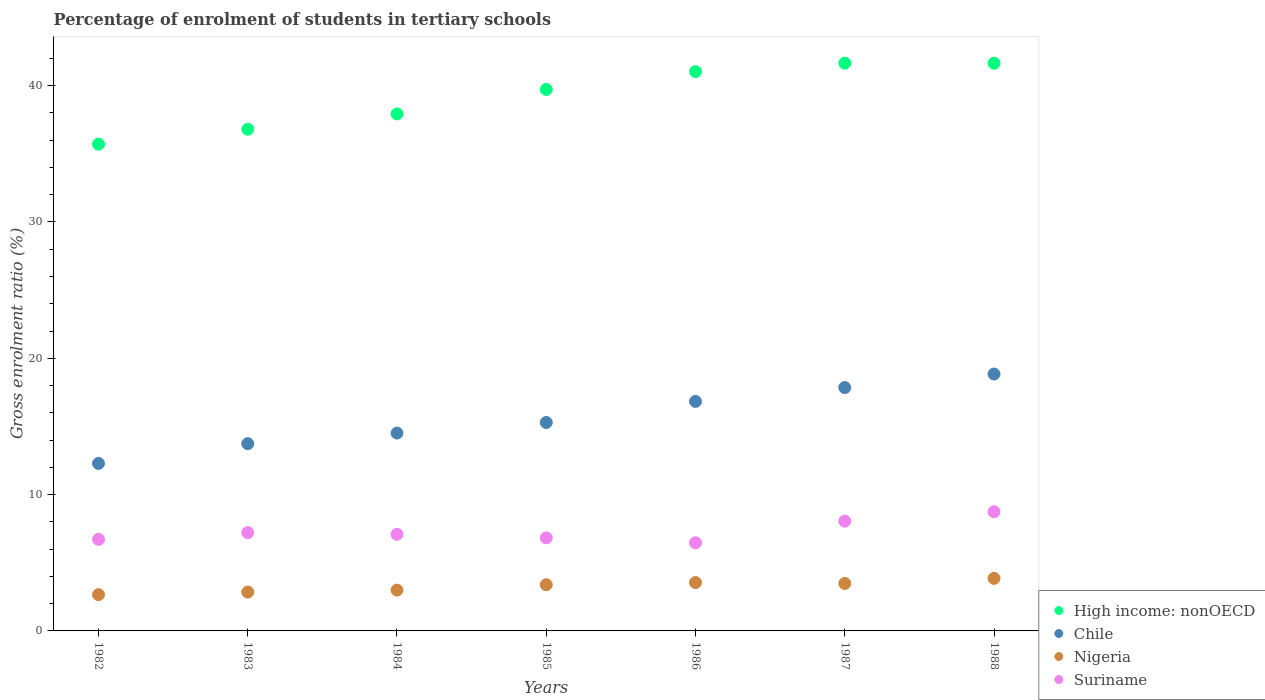Is the number of dotlines equal to the number of legend labels?
Give a very brief answer. Yes. What is the percentage of students enrolled in tertiary schools in Chile in 1984?
Provide a succinct answer. 14.51. Across all years, what is the maximum percentage of students enrolled in tertiary schools in Nigeria?
Your response must be concise. 3.85. Across all years, what is the minimum percentage of students enrolled in tertiary schools in Chile?
Keep it short and to the point. 12.29. In which year was the percentage of students enrolled in tertiary schools in Chile minimum?
Offer a terse response. 1982. What is the total percentage of students enrolled in tertiary schools in Nigeria in the graph?
Your response must be concise. 22.78. What is the difference between the percentage of students enrolled in tertiary schools in Suriname in 1984 and that in 1988?
Give a very brief answer. -1.66. What is the difference between the percentage of students enrolled in tertiary schools in High income: nonOECD in 1983 and the percentage of students enrolled in tertiary schools in Suriname in 1986?
Your answer should be compact. 30.33. What is the average percentage of students enrolled in tertiary schools in High income: nonOECD per year?
Ensure brevity in your answer.  39.21. In the year 1982, what is the difference between the percentage of students enrolled in tertiary schools in Chile and percentage of students enrolled in tertiary schools in Nigeria?
Make the answer very short. 9.63. In how many years, is the percentage of students enrolled in tertiary schools in High income: nonOECD greater than 8 %?
Your answer should be compact. 7. What is the ratio of the percentage of students enrolled in tertiary schools in Nigeria in 1982 to that in 1984?
Your response must be concise. 0.89. Is the percentage of students enrolled in tertiary schools in Suriname in 1987 less than that in 1988?
Offer a very short reply. Yes. What is the difference between the highest and the second highest percentage of students enrolled in tertiary schools in High income: nonOECD?
Offer a very short reply. 0.01. What is the difference between the highest and the lowest percentage of students enrolled in tertiary schools in Suriname?
Give a very brief answer. 2.28. In how many years, is the percentage of students enrolled in tertiary schools in Chile greater than the average percentage of students enrolled in tertiary schools in Chile taken over all years?
Keep it short and to the point. 3. Is it the case that in every year, the sum of the percentage of students enrolled in tertiary schools in Nigeria and percentage of students enrolled in tertiary schools in Suriname  is greater than the sum of percentage of students enrolled in tertiary schools in Chile and percentage of students enrolled in tertiary schools in High income: nonOECD?
Offer a terse response. Yes. Does the percentage of students enrolled in tertiary schools in Nigeria monotonically increase over the years?
Offer a terse response. No. Is the percentage of students enrolled in tertiary schools in Chile strictly greater than the percentage of students enrolled in tertiary schools in Suriname over the years?
Your answer should be compact. Yes. Is the percentage of students enrolled in tertiary schools in High income: nonOECD strictly less than the percentage of students enrolled in tertiary schools in Nigeria over the years?
Provide a short and direct response. No. How many dotlines are there?
Your answer should be very brief. 4. Are the values on the major ticks of Y-axis written in scientific E-notation?
Give a very brief answer. No. Does the graph contain any zero values?
Make the answer very short. No. Does the graph contain grids?
Your answer should be compact. No. How are the legend labels stacked?
Your answer should be very brief. Vertical. What is the title of the graph?
Offer a very short reply. Percentage of enrolment of students in tertiary schools. What is the label or title of the X-axis?
Make the answer very short. Years. What is the Gross enrolment ratio (%) of High income: nonOECD in 1982?
Give a very brief answer. 35.71. What is the Gross enrolment ratio (%) in Chile in 1982?
Offer a terse response. 12.29. What is the Gross enrolment ratio (%) of Nigeria in 1982?
Provide a succinct answer. 2.66. What is the Gross enrolment ratio (%) of Suriname in 1982?
Your answer should be compact. 6.72. What is the Gross enrolment ratio (%) of High income: nonOECD in 1983?
Give a very brief answer. 36.8. What is the Gross enrolment ratio (%) in Chile in 1983?
Offer a terse response. 13.74. What is the Gross enrolment ratio (%) of Nigeria in 1983?
Your answer should be very brief. 2.85. What is the Gross enrolment ratio (%) in Suriname in 1983?
Your answer should be compact. 7.21. What is the Gross enrolment ratio (%) in High income: nonOECD in 1984?
Your response must be concise. 37.92. What is the Gross enrolment ratio (%) of Chile in 1984?
Your answer should be very brief. 14.51. What is the Gross enrolment ratio (%) of Nigeria in 1984?
Provide a short and direct response. 2.99. What is the Gross enrolment ratio (%) of Suriname in 1984?
Make the answer very short. 7.09. What is the Gross enrolment ratio (%) of High income: nonOECD in 1985?
Ensure brevity in your answer.  39.72. What is the Gross enrolment ratio (%) of Chile in 1985?
Offer a terse response. 15.29. What is the Gross enrolment ratio (%) of Nigeria in 1985?
Ensure brevity in your answer.  3.39. What is the Gross enrolment ratio (%) of Suriname in 1985?
Offer a terse response. 6.83. What is the Gross enrolment ratio (%) of High income: nonOECD in 1986?
Give a very brief answer. 41.03. What is the Gross enrolment ratio (%) of Chile in 1986?
Ensure brevity in your answer.  16.84. What is the Gross enrolment ratio (%) in Nigeria in 1986?
Make the answer very short. 3.55. What is the Gross enrolment ratio (%) in Suriname in 1986?
Make the answer very short. 6.47. What is the Gross enrolment ratio (%) in High income: nonOECD in 1987?
Your response must be concise. 41.65. What is the Gross enrolment ratio (%) of Chile in 1987?
Your response must be concise. 17.85. What is the Gross enrolment ratio (%) in Nigeria in 1987?
Provide a succinct answer. 3.48. What is the Gross enrolment ratio (%) of Suriname in 1987?
Your response must be concise. 8.05. What is the Gross enrolment ratio (%) of High income: nonOECD in 1988?
Make the answer very short. 41.64. What is the Gross enrolment ratio (%) of Chile in 1988?
Offer a very short reply. 18.84. What is the Gross enrolment ratio (%) in Nigeria in 1988?
Your answer should be very brief. 3.85. What is the Gross enrolment ratio (%) in Suriname in 1988?
Provide a short and direct response. 8.74. Across all years, what is the maximum Gross enrolment ratio (%) in High income: nonOECD?
Provide a short and direct response. 41.65. Across all years, what is the maximum Gross enrolment ratio (%) in Chile?
Your response must be concise. 18.84. Across all years, what is the maximum Gross enrolment ratio (%) of Nigeria?
Provide a short and direct response. 3.85. Across all years, what is the maximum Gross enrolment ratio (%) in Suriname?
Offer a very short reply. 8.74. Across all years, what is the minimum Gross enrolment ratio (%) of High income: nonOECD?
Your response must be concise. 35.71. Across all years, what is the minimum Gross enrolment ratio (%) in Chile?
Offer a very short reply. 12.29. Across all years, what is the minimum Gross enrolment ratio (%) of Nigeria?
Provide a short and direct response. 2.66. Across all years, what is the minimum Gross enrolment ratio (%) of Suriname?
Make the answer very short. 6.47. What is the total Gross enrolment ratio (%) in High income: nonOECD in the graph?
Provide a succinct answer. 274.47. What is the total Gross enrolment ratio (%) in Chile in the graph?
Your response must be concise. 109.36. What is the total Gross enrolment ratio (%) of Nigeria in the graph?
Your answer should be very brief. 22.78. What is the total Gross enrolment ratio (%) of Suriname in the graph?
Provide a short and direct response. 51.1. What is the difference between the Gross enrolment ratio (%) in High income: nonOECD in 1982 and that in 1983?
Provide a short and direct response. -1.09. What is the difference between the Gross enrolment ratio (%) of Chile in 1982 and that in 1983?
Provide a short and direct response. -1.45. What is the difference between the Gross enrolment ratio (%) of Nigeria in 1982 and that in 1983?
Keep it short and to the point. -0.19. What is the difference between the Gross enrolment ratio (%) in Suriname in 1982 and that in 1983?
Keep it short and to the point. -0.49. What is the difference between the Gross enrolment ratio (%) of High income: nonOECD in 1982 and that in 1984?
Your answer should be compact. -2.22. What is the difference between the Gross enrolment ratio (%) in Chile in 1982 and that in 1984?
Your response must be concise. -2.23. What is the difference between the Gross enrolment ratio (%) in Nigeria in 1982 and that in 1984?
Ensure brevity in your answer.  -0.33. What is the difference between the Gross enrolment ratio (%) of Suriname in 1982 and that in 1984?
Provide a short and direct response. -0.37. What is the difference between the Gross enrolment ratio (%) of High income: nonOECD in 1982 and that in 1985?
Make the answer very short. -4.01. What is the difference between the Gross enrolment ratio (%) of Chile in 1982 and that in 1985?
Make the answer very short. -3. What is the difference between the Gross enrolment ratio (%) of Nigeria in 1982 and that in 1985?
Ensure brevity in your answer.  -0.73. What is the difference between the Gross enrolment ratio (%) of Suriname in 1982 and that in 1985?
Your response must be concise. -0.11. What is the difference between the Gross enrolment ratio (%) in High income: nonOECD in 1982 and that in 1986?
Ensure brevity in your answer.  -5.32. What is the difference between the Gross enrolment ratio (%) of Chile in 1982 and that in 1986?
Ensure brevity in your answer.  -4.55. What is the difference between the Gross enrolment ratio (%) of Nigeria in 1982 and that in 1986?
Provide a short and direct response. -0.89. What is the difference between the Gross enrolment ratio (%) of Suriname in 1982 and that in 1986?
Your answer should be very brief. 0.25. What is the difference between the Gross enrolment ratio (%) in High income: nonOECD in 1982 and that in 1987?
Provide a short and direct response. -5.94. What is the difference between the Gross enrolment ratio (%) of Chile in 1982 and that in 1987?
Provide a succinct answer. -5.56. What is the difference between the Gross enrolment ratio (%) in Nigeria in 1982 and that in 1987?
Your answer should be compact. -0.82. What is the difference between the Gross enrolment ratio (%) of Suriname in 1982 and that in 1987?
Your answer should be compact. -1.33. What is the difference between the Gross enrolment ratio (%) in High income: nonOECD in 1982 and that in 1988?
Your response must be concise. -5.93. What is the difference between the Gross enrolment ratio (%) in Chile in 1982 and that in 1988?
Give a very brief answer. -6.56. What is the difference between the Gross enrolment ratio (%) of Nigeria in 1982 and that in 1988?
Keep it short and to the point. -1.19. What is the difference between the Gross enrolment ratio (%) in Suriname in 1982 and that in 1988?
Your answer should be compact. -2.02. What is the difference between the Gross enrolment ratio (%) of High income: nonOECD in 1983 and that in 1984?
Your answer should be very brief. -1.12. What is the difference between the Gross enrolment ratio (%) of Chile in 1983 and that in 1984?
Provide a succinct answer. -0.78. What is the difference between the Gross enrolment ratio (%) in Nigeria in 1983 and that in 1984?
Your answer should be very brief. -0.14. What is the difference between the Gross enrolment ratio (%) in Suriname in 1983 and that in 1984?
Provide a succinct answer. 0.12. What is the difference between the Gross enrolment ratio (%) in High income: nonOECD in 1983 and that in 1985?
Ensure brevity in your answer.  -2.92. What is the difference between the Gross enrolment ratio (%) of Chile in 1983 and that in 1985?
Your answer should be compact. -1.55. What is the difference between the Gross enrolment ratio (%) in Nigeria in 1983 and that in 1985?
Provide a succinct answer. -0.54. What is the difference between the Gross enrolment ratio (%) in Suriname in 1983 and that in 1985?
Offer a terse response. 0.38. What is the difference between the Gross enrolment ratio (%) of High income: nonOECD in 1983 and that in 1986?
Offer a very short reply. -4.23. What is the difference between the Gross enrolment ratio (%) in Chile in 1983 and that in 1986?
Your response must be concise. -3.1. What is the difference between the Gross enrolment ratio (%) of Nigeria in 1983 and that in 1986?
Provide a short and direct response. -0.7. What is the difference between the Gross enrolment ratio (%) in Suriname in 1983 and that in 1986?
Keep it short and to the point. 0.74. What is the difference between the Gross enrolment ratio (%) in High income: nonOECD in 1983 and that in 1987?
Make the answer very short. -4.85. What is the difference between the Gross enrolment ratio (%) of Chile in 1983 and that in 1987?
Provide a short and direct response. -4.11. What is the difference between the Gross enrolment ratio (%) in Nigeria in 1983 and that in 1987?
Keep it short and to the point. -0.63. What is the difference between the Gross enrolment ratio (%) of Suriname in 1983 and that in 1987?
Your response must be concise. -0.84. What is the difference between the Gross enrolment ratio (%) in High income: nonOECD in 1983 and that in 1988?
Make the answer very short. -4.84. What is the difference between the Gross enrolment ratio (%) in Chile in 1983 and that in 1988?
Your response must be concise. -5.11. What is the difference between the Gross enrolment ratio (%) of Nigeria in 1983 and that in 1988?
Make the answer very short. -1. What is the difference between the Gross enrolment ratio (%) of Suriname in 1983 and that in 1988?
Offer a terse response. -1.53. What is the difference between the Gross enrolment ratio (%) in High income: nonOECD in 1984 and that in 1985?
Your answer should be compact. -1.8. What is the difference between the Gross enrolment ratio (%) of Chile in 1984 and that in 1985?
Provide a succinct answer. -0.77. What is the difference between the Gross enrolment ratio (%) in Nigeria in 1984 and that in 1985?
Provide a short and direct response. -0.4. What is the difference between the Gross enrolment ratio (%) in Suriname in 1984 and that in 1985?
Provide a short and direct response. 0.26. What is the difference between the Gross enrolment ratio (%) of High income: nonOECD in 1984 and that in 1986?
Keep it short and to the point. -3.1. What is the difference between the Gross enrolment ratio (%) in Chile in 1984 and that in 1986?
Your response must be concise. -2.32. What is the difference between the Gross enrolment ratio (%) of Nigeria in 1984 and that in 1986?
Offer a terse response. -0.55. What is the difference between the Gross enrolment ratio (%) in Suriname in 1984 and that in 1986?
Provide a short and direct response. 0.62. What is the difference between the Gross enrolment ratio (%) in High income: nonOECD in 1984 and that in 1987?
Provide a short and direct response. -3.72. What is the difference between the Gross enrolment ratio (%) of Chile in 1984 and that in 1987?
Provide a succinct answer. -3.34. What is the difference between the Gross enrolment ratio (%) in Nigeria in 1984 and that in 1987?
Your answer should be compact. -0.49. What is the difference between the Gross enrolment ratio (%) of Suriname in 1984 and that in 1987?
Ensure brevity in your answer.  -0.97. What is the difference between the Gross enrolment ratio (%) in High income: nonOECD in 1984 and that in 1988?
Offer a very short reply. -3.72. What is the difference between the Gross enrolment ratio (%) in Chile in 1984 and that in 1988?
Give a very brief answer. -4.33. What is the difference between the Gross enrolment ratio (%) of Nigeria in 1984 and that in 1988?
Make the answer very short. -0.86. What is the difference between the Gross enrolment ratio (%) of Suriname in 1984 and that in 1988?
Keep it short and to the point. -1.66. What is the difference between the Gross enrolment ratio (%) of High income: nonOECD in 1985 and that in 1986?
Offer a very short reply. -1.31. What is the difference between the Gross enrolment ratio (%) in Chile in 1985 and that in 1986?
Make the answer very short. -1.55. What is the difference between the Gross enrolment ratio (%) of Nigeria in 1985 and that in 1986?
Provide a succinct answer. -0.16. What is the difference between the Gross enrolment ratio (%) in Suriname in 1985 and that in 1986?
Offer a terse response. 0.36. What is the difference between the Gross enrolment ratio (%) in High income: nonOECD in 1985 and that in 1987?
Provide a succinct answer. -1.93. What is the difference between the Gross enrolment ratio (%) of Chile in 1985 and that in 1987?
Offer a very short reply. -2.56. What is the difference between the Gross enrolment ratio (%) of Nigeria in 1985 and that in 1987?
Keep it short and to the point. -0.09. What is the difference between the Gross enrolment ratio (%) in Suriname in 1985 and that in 1987?
Give a very brief answer. -1.23. What is the difference between the Gross enrolment ratio (%) of High income: nonOECD in 1985 and that in 1988?
Your answer should be very brief. -1.92. What is the difference between the Gross enrolment ratio (%) of Chile in 1985 and that in 1988?
Offer a terse response. -3.56. What is the difference between the Gross enrolment ratio (%) of Nigeria in 1985 and that in 1988?
Offer a terse response. -0.47. What is the difference between the Gross enrolment ratio (%) of Suriname in 1985 and that in 1988?
Your answer should be very brief. -1.92. What is the difference between the Gross enrolment ratio (%) in High income: nonOECD in 1986 and that in 1987?
Your response must be concise. -0.62. What is the difference between the Gross enrolment ratio (%) in Chile in 1986 and that in 1987?
Provide a succinct answer. -1.02. What is the difference between the Gross enrolment ratio (%) of Nigeria in 1986 and that in 1987?
Your answer should be compact. 0.07. What is the difference between the Gross enrolment ratio (%) in Suriname in 1986 and that in 1987?
Provide a succinct answer. -1.59. What is the difference between the Gross enrolment ratio (%) in High income: nonOECD in 1986 and that in 1988?
Provide a short and direct response. -0.61. What is the difference between the Gross enrolment ratio (%) of Chile in 1986 and that in 1988?
Keep it short and to the point. -2.01. What is the difference between the Gross enrolment ratio (%) of Nigeria in 1986 and that in 1988?
Keep it short and to the point. -0.31. What is the difference between the Gross enrolment ratio (%) in Suriname in 1986 and that in 1988?
Ensure brevity in your answer.  -2.28. What is the difference between the Gross enrolment ratio (%) of High income: nonOECD in 1987 and that in 1988?
Give a very brief answer. 0.01. What is the difference between the Gross enrolment ratio (%) of Chile in 1987 and that in 1988?
Give a very brief answer. -0.99. What is the difference between the Gross enrolment ratio (%) of Nigeria in 1987 and that in 1988?
Keep it short and to the point. -0.37. What is the difference between the Gross enrolment ratio (%) in Suriname in 1987 and that in 1988?
Your answer should be very brief. -0.69. What is the difference between the Gross enrolment ratio (%) in High income: nonOECD in 1982 and the Gross enrolment ratio (%) in Chile in 1983?
Make the answer very short. 21.97. What is the difference between the Gross enrolment ratio (%) in High income: nonOECD in 1982 and the Gross enrolment ratio (%) in Nigeria in 1983?
Your answer should be very brief. 32.86. What is the difference between the Gross enrolment ratio (%) in High income: nonOECD in 1982 and the Gross enrolment ratio (%) in Suriname in 1983?
Provide a succinct answer. 28.5. What is the difference between the Gross enrolment ratio (%) of Chile in 1982 and the Gross enrolment ratio (%) of Nigeria in 1983?
Your answer should be compact. 9.44. What is the difference between the Gross enrolment ratio (%) of Chile in 1982 and the Gross enrolment ratio (%) of Suriname in 1983?
Offer a terse response. 5.08. What is the difference between the Gross enrolment ratio (%) in Nigeria in 1982 and the Gross enrolment ratio (%) in Suriname in 1983?
Offer a very short reply. -4.55. What is the difference between the Gross enrolment ratio (%) of High income: nonOECD in 1982 and the Gross enrolment ratio (%) of Chile in 1984?
Your answer should be very brief. 21.19. What is the difference between the Gross enrolment ratio (%) of High income: nonOECD in 1982 and the Gross enrolment ratio (%) of Nigeria in 1984?
Provide a succinct answer. 32.71. What is the difference between the Gross enrolment ratio (%) of High income: nonOECD in 1982 and the Gross enrolment ratio (%) of Suriname in 1984?
Keep it short and to the point. 28.62. What is the difference between the Gross enrolment ratio (%) in Chile in 1982 and the Gross enrolment ratio (%) in Nigeria in 1984?
Your answer should be compact. 9.29. What is the difference between the Gross enrolment ratio (%) of Chile in 1982 and the Gross enrolment ratio (%) of Suriname in 1984?
Your response must be concise. 5.2. What is the difference between the Gross enrolment ratio (%) of Nigeria in 1982 and the Gross enrolment ratio (%) of Suriname in 1984?
Your response must be concise. -4.43. What is the difference between the Gross enrolment ratio (%) in High income: nonOECD in 1982 and the Gross enrolment ratio (%) in Chile in 1985?
Keep it short and to the point. 20.42. What is the difference between the Gross enrolment ratio (%) of High income: nonOECD in 1982 and the Gross enrolment ratio (%) of Nigeria in 1985?
Offer a terse response. 32.32. What is the difference between the Gross enrolment ratio (%) of High income: nonOECD in 1982 and the Gross enrolment ratio (%) of Suriname in 1985?
Provide a short and direct response. 28.88. What is the difference between the Gross enrolment ratio (%) in Chile in 1982 and the Gross enrolment ratio (%) in Nigeria in 1985?
Give a very brief answer. 8.9. What is the difference between the Gross enrolment ratio (%) of Chile in 1982 and the Gross enrolment ratio (%) of Suriname in 1985?
Offer a very short reply. 5.46. What is the difference between the Gross enrolment ratio (%) in Nigeria in 1982 and the Gross enrolment ratio (%) in Suriname in 1985?
Your answer should be very brief. -4.17. What is the difference between the Gross enrolment ratio (%) in High income: nonOECD in 1982 and the Gross enrolment ratio (%) in Chile in 1986?
Your answer should be very brief. 18.87. What is the difference between the Gross enrolment ratio (%) in High income: nonOECD in 1982 and the Gross enrolment ratio (%) in Nigeria in 1986?
Provide a succinct answer. 32.16. What is the difference between the Gross enrolment ratio (%) of High income: nonOECD in 1982 and the Gross enrolment ratio (%) of Suriname in 1986?
Provide a succinct answer. 29.24. What is the difference between the Gross enrolment ratio (%) in Chile in 1982 and the Gross enrolment ratio (%) in Nigeria in 1986?
Provide a succinct answer. 8.74. What is the difference between the Gross enrolment ratio (%) in Chile in 1982 and the Gross enrolment ratio (%) in Suriname in 1986?
Offer a terse response. 5.82. What is the difference between the Gross enrolment ratio (%) of Nigeria in 1982 and the Gross enrolment ratio (%) of Suriname in 1986?
Your response must be concise. -3.81. What is the difference between the Gross enrolment ratio (%) in High income: nonOECD in 1982 and the Gross enrolment ratio (%) in Chile in 1987?
Ensure brevity in your answer.  17.86. What is the difference between the Gross enrolment ratio (%) in High income: nonOECD in 1982 and the Gross enrolment ratio (%) in Nigeria in 1987?
Provide a short and direct response. 32.23. What is the difference between the Gross enrolment ratio (%) of High income: nonOECD in 1982 and the Gross enrolment ratio (%) of Suriname in 1987?
Offer a terse response. 27.65. What is the difference between the Gross enrolment ratio (%) in Chile in 1982 and the Gross enrolment ratio (%) in Nigeria in 1987?
Offer a terse response. 8.81. What is the difference between the Gross enrolment ratio (%) in Chile in 1982 and the Gross enrolment ratio (%) in Suriname in 1987?
Your answer should be compact. 4.23. What is the difference between the Gross enrolment ratio (%) in Nigeria in 1982 and the Gross enrolment ratio (%) in Suriname in 1987?
Keep it short and to the point. -5.39. What is the difference between the Gross enrolment ratio (%) of High income: nonOECD in 1982 and the Gross enrolment ratio (%) of Chile in 1988?
Ensure brevity in your answer.  16.86. What is the difference between the Gross enrolment ratio (%) in High income: nonOECD in 1982 and the Gross enrolment ratio (%) in Nigeria in 1988?
Make the answer very short. 31.85. What is the difference between the Gross enrolment ratio (%) in High income: nonOECD in 1982 and the Gross enrolment ratio (%) in Suriname in 1988?
Provide a short and direct response. 26.96. What is the difference between the Gross enrolment ratio (%) in Chile in 1982 and the Gross enrolment ratio (%) in Nigeria in 1988?
Ensure brevity in your answer.  8.43. What is the difference between the Gross enrolment ratio (%) of Chile in 1982 and the Gross enrolment ratio (%) of Suriname in 1988?
Offer a very short reply. 3.54. What is the difference between the Gross enrolment ratio (%) in Nigeria in 1982 and the Gross enrolment ratio (%) in Suriname in 1988?
Make the answer very short. -6.08. What is the difference between the Gross enrolment ratio (%) of High income: nonOECD in 1983 and the Gross enrolment ratio (%) of Chile in 1984?
Offer a very short reply. 22.29. What is the difference between the Gross enrolment ratio (%) of High income: nonOECD in 1983 and the Gross enrolment ratio (%) of Nigeria in 1984?
Give a very brief answer. 33.81. What is the difference between the Gross enrolment ratio (%) of High income: nonOECD in 1983 and the Gross enrolment ratio (%) of Suriname in 1984?
Ensure brevity in your answer.  29.72. What is the difference between the Gross enrolment ratio (%) of Chile in 1983 and the Gross enrolment ratio (%) of Nigeria in 1984?
Provide a succinct answer. 10.74. What is the difference between the Gross enrolment ratio (%) in Chile in 1983 and the Gross enrolment ratio (%) in Suriname in 1984?
Your response must be concise. 6.65. What is the difference between the Gross enrolment ratio (%) in Nigeria in 1983 and the Gross enrolment ratio (%) in Suriname in 1984?
Provide a succinct answer. -4.24. What is the difference between the Gross enrolment ratio (%) of High income: nonOECD in 1983 and the Gross enrolment ratio (%) of Chile in 1985?
Keep it short and to the point. 21.51. What is the difference between the Gross enrolment ratio (%) in High income: nonOECD in 1983 and the Gross enrolment ratio (%) in Nigeria in 1985?
Your response must be concise. 33.41. What is the difference between the Gross enrolment ratio (%) in High income: nonOECD in 1983 and the Gross enrolment ratio (%) in Suriname in 1985?
Your response must be concise. 29.98. What is the difference between the Gross enrolment ratio (%) of Chile in 1983 and the Gross enrolment ratio (%) of Nigeria in 1985?
Give a very brief answer. 10.35. What is the difference between the Gross enrolment ratio (%) in Chile in 1983 and the Gross enrolment ratio (%) in Suriname in 1985?
Your answer should be very brief. 6.91. What is the difference between the Gross enrolment ratio (%) of Nigeria in 1983 and the Gross enrolment ratio (%) of Suriname in 1985?
Offer a terse response. -3.98. What is the difference between the Gross enrolment ratio (%) in High income: nonOECD in 1983 and the Gross enrolment ratio (%) in Chile in 1986?
Your answer should be very brief. 19.97. What is the difference between the Gross enrolment ratio (%) of High income: nonOECD in 1983 and the Gross enrolment ratio (%) of Nigeria in 1986?
Offer a very short reply. 33.26. What is the difference between the Gross enrolment ratio (%) in High income: nonOECD in 1983 and the Gross enrolment ratio (%) in Suriname in 1986?
Provide a short and direct response. 30.33. What is the difference between the Gross enrolment ratio (%) in Chile in 1983 and the Gross enrolment ratio (%) in Nigeria in 1986?
Give a very brief answer. 10.19. What is the difference between the Gross enrolment ratio (%) of Chile in 1983 and the Gross enrolment ratio (%) of Suriname in 1986?
Your response must be concise. 7.27. What is the difference between the Gross enrolment ratio (%) in Nigeria in 1983 and the Gross enrolment ratio (%) in Suriname in 1986?
Your answer should be very brief. -3.62. What is the difference between the Gross enrolment ratio (%) in High income: nonOECD in 1983 and the Gross enrolment ratio (%) in Chile in 1987?
Your response must be concise. 18.95. What is the difference between the Gross enrolment ratio (%) of High income: nonOECD in 1983 and the Gross enrolment ratio (%) of Nigeria in 1987?
Keep it short and to the point. 33.32. What is the difference between the Gross enrolment ratio (%) in High income: nonOECD in 1983 and the Gross enrolment ratio (%) in Suriname in 1987?
Make the answer very short. 28.75. What is the difference between the Gross enrolment ratio (%) of Chile in 1983 and the Gross enrolment ratio (%) of Nigeria in 1987?
Offer a terse response. 10.26. What is the difference between the Gross enrolment ratio (%) of Chile in 1983 and the Gross enrolment ratio (%) of Suriname in 1987?
Your answer should be very brief. 5.68. What is the difference between the Gross enrolment ratio (%) of Nigeria in 1983 and the Gross enrolment ratio (%) of Suriname in 1987?
Ensure brevity in your answer.  -5.2. What is the difference between the Gross enrolment ratio (%) of High income: nonOECD in 1983 and the Gross enrolment ratio (%) of Chile in 1988?
Offer a very short reply. 17.96. What is the difference between the Gross enrolment ratio (%) of High income: nonOECD in 1983 and the Gross enrolment ratio (%) of Nigeria in 1988?
Your answer should be very brief. 32.95. What is the difference between the Gross enrolment ratio (%) in High income: nonOECD in 1983 and the Gross enrolment ratio (%) in Suriname in 1988?
Give a very brief answer. 28.06. What is the difference between the Gross enrolment ratio (%) in Chile in 1983 and the Gross enrolment ratio (%) in Nigeria in 1988?
Provide a short and direct response. 9.88. What is the difference between the Gross enrolment ratio (%) of Chile in 1983 and the Gross enrolment ratio (%) of Suriname in 1988?
Make the answer very short. 4.99. What is the difference between the Gross enrolment ratio (%) in Nigeria in 1983 and the Gross enrolment ratio (%) in Suriname in 1988?
Your response must be concise. -5.89. What is the difference between the Gross enrolment ratio (%) of High income: nonOECD in 1984 and the Gross enrolment ratio (%) of Chile in 1985?
Offer a terse response. 22.64. What is the difference between the Gross enrolment ratio (%) of High income: nonOECD in 1984 and the Gross enrolment ratio (%) of Nigeria in 1985?
Offer a terse response. 34.53. What is the difference between the Gross enrolment ratio (%) in High income: nonOECD in 1984 and the Gross enrolment ratio (%) in Suriname in 1985?
Ensure brevity in your answer.  31.1. What is the difference between the Gross enrolment ratio (%) of Chile in 1984 and the Gross enrolment ratio (%) of Nigeria in 1985?
Offer a very short reply. 11.12. What is the difference between the Gross enrolment ratio (%) of Chile in 1984 and the Gross enrolment ratio (%) of Suriname in 1985?
Ensure brevity in your answer.  7.69. What is the difference between the Gross enrolment ratio (%) in Nigeria in 1984 and the Gross enrolment ratio (%) in Suriname in 1985?
Give a very brief answer. -3.83. What is the difference between the Gross enrolment ratio (%) in High income: nonOECD in 1984 and the Gross enrolment ratio (%) in Chile in 1986?
Keep it short and to the point. 21.09. What is the difference between the Gross enrolment ratio (%) of High income: nonOECD in 1984 and the Gross enrolment ratio (%) of Nigeria in 1986?
Make the answer very short. 34.38. What is the difference between the Gross enrolment ratio (%) of High income: nonOECD in 1984 and the Gross enrolment ratio (%) of Suriname in 1986?
Give a very brief answer. 31.46. What is the difference between the Gross enrolment ratio (%) in Chile in 1984 and the Gross enrolment ratio (%) in Nigeria in 1986?
Ensure brevity in your answer.  10.97. What is the difference between the Gross enrolment ratio (%) of Chile in 1984 and the Gross enrolment ratio (%) of Suriname in 1986?
Ensure brevity in your answer.  8.05. What is the difference between the Gross enrolment ratio (%) in Nigeria in 1984 and the Gross enrolment ratio (%) in Suriname in 1986?
Your response must be concise. -3.47. What is the difference between the Gross enrolment ratio (%) in High income: nonOECD in 1984 and the Gross enrolment ratio (%) in Chile in 1987?
Make the answer very short. 20.07. What is the difference between the Gross enrolment ratio (%) in High income: nonOECD in 1984 and the Gross enrolment ratio (%) in Nigeria in 1987?
Offer a terse response. 34.44. What is the difference between the Gross enrolment ratio (%) in High income: nonOECD in 1984 and the Gross enrolment ratio (%) in Suriname in 1987?
Offer a very short reply. 29.87. What is the difference between the Gross enrolment ratio (%) of Chile in 1984 and the Gross enrolment ratio (%) of Nigeria in 1987?
Offer a very short reply. 11.03. What is the difference between the Gross enrolment ratio (%) in Chile in 1984 and the Gross enrolment ratio (%) in Suriname in 1987?
Your answer should be compact. 6.46. What is the difference between the Gross enrolment ratio (%) of Nigeria in 1984 and the Gross enrolment ratio (%) of Suriname in 1987?
Offer a terse response. -5.06. What is the difference between the Gross enrolment ratio (%) in High income: nonOECD in 1984 and the Gross enrolment ratio (%) in Chile in 1988?
Your response must be concise. 19.08. What is the difference between the Gross enrolment ratio (%) of High income: nonOECD in 1984 and the Gross enrolment ratio (%) of Nigeria in 1988?
Offer a terse response. 34.07. What is the difference between the Gross enrolment ratio (%) of High income: nonOECD in 1984 and the Gross enrolment ratio (%) of Suriname in 1988?
Provide a short and direct response. 29.18. What is the difference between the Gross enrolment ratio (%) in Chile in 1984 and the Gross enrolment ratio (%) in Nigeria in 1988?
Your answer should be compact. 10.66. What is the difference between the Gross enrolment ratio (%) in Chile in 1984 and the Gross enrolment ratio (%) in Suriname in 1988?
Make the answer very short. 5.77. What is the difference between the Gross enrolment ratio (%) in Nigeria in 1984 and the Gross enrolment ratio (%) in Suriname in 1988?
Keep it short and to the point. -5.75. What is the difference between the Gross enrolment ratio (%) in High income: nonOECD in 1985 and the Gross enrolment ratio (%) in Chile in 1986?
Your answer should be very brief. 22.89. What is the difference between the Gross enrolment ratio (%) in High income: nonOECD in 1985 and the Gross enrolment ratio (%) in Nigeria in 1986?
Offer a terse response. 36.17. What is the difference between the Gross enrolment ratio (%) in High income: nonOECD in 1985 and the Gross enrolment ratio (%) in Suriname in 1986?
Offer a terse response. 33.25. What is the difference between the Gross enrolment ratio (%) in Chile in 1985 and the Gross enrolment ratio (%) in Nigeria in 1986?
Ensure brevity in your answer.  11.74. What is the difference between the Gross enrolment ratio (%) in Chile in 1985 and the Gross enrolment ratio (%) in Suriname in 1986?
Make the answer very short. 8.82. What is the difference between the Gross enrolment ratio (%) of Nigeria in 1985 and the Gross enrolment ratio (%) of Suriname in 1986?
Make the answer very short. -3.08. What is the difference between the Gross enrolment ratio (%) in High income: nonOECD in 1985 and the Gross enrolment ratio (%) in Chile in 1987?
Keep it short and to the point. 21.87. What is the difference between the Gross enrolment ratio (%) in High income: nonOECD in 1985 and the Gross enrolment ratio (%) in Nigeria in 1987?
Offer a terse response. 36.24. What is the difference between the Gross enrolment ratio (%) in High income: nonOECD in 1985 and the Gross enrolment ratio (%) in Suriname in 1987?
Provide a short and direct response. 31.67. What is the difference between the Gross enrolment ratio (%) of Chile in 1985 and the Gross enrolment ratio (%) of Nigeria in 1987?
Ensure brevity in your answer.  11.81. What is the difference between the Gross enrolment ratio (%) in Chile in 1985 and the Gross enrolment ratio (%) in Suriname in 1987?
Offer a very short reply. 7.23. What is the difference between the Gross enrolment ratio (%) of Nigeria in 1985 and the Gross enrolment ratio (%) of Suriname in 1987?
Your response must be concise. -4.66. What is the difference between the Gross enrolment ratio (%) of High income: nonOECD in 1985 and the Gross enrolment ratio (%) of Chile in 1988?
Your answer should be compact. 20.88. What is the difference between the Gross enrolment ratio (%) of High income: nonOECD in 1985 and the Gross enrolment ratio (%) of Nigeria in 1988?
Ensure brevity in your answer.  35.87. What is the difference between the Gross enrolment ratio (%) of High income: nonOECD in 1985 and the Gross enrolment ratio (%) of Suriname in 1988?
Your response must be concise. 30.98. What is the difference between the Gross enrolment ratio (%) in Chile in 1985 and the Gross enrolment ratio (%) in Nigeria in 1988?
Offer a very short reply. 11.43. What is the difference between the Gross enrolment ratio (%) of Chile in 1985 and the Gross enrolment ratio (%) of Suriname in 1988?
Ensure brevity in your answer.  6.55. What is the difference between the Gross enrolment ratio (%) in Nigeria in 1985 and the Gross enrolment ratio (%) in Suriname in 1988?
Ensure brevity in your answer.  -5.35. What is the difference between the Gross enrolment ratio (%) of High income: nonOECD in 1986 and the Gross enrolment ratio (%) of Chile in 1987?
Provide a succinct answer. 23.18. What is the difference between the Gross enrolment ratio (%) in High income: nonOECD in 1986 and the Gross enrolment ratio (%) in Nigeria in 1987?
Offer a very short reply. 37.55. What is the difference between the Gross enrolment ratio (%) of High income: nonOECD in 1986 and the Gross enrolment ratio (%) of Suriname in 1987?
Keep it short and to the point. 32.98. What is the difference between the Gross enrolment ratio (%) of Chile in 1986 and the Gross enrolment ratio (%) of Nigeria in 1987?
Your answer should be very brief. 13.35. What is the difference between the Gross enrolment ratio (%) of Chile in 1986 and the Gross enrolment ratio (%) of Suriname in 1987?
Your answer should be compact. 8.78. What is the difference between the Gross enrolment ratio (%) of Nigeria in 1986 and the Gross enrolment ratio (%) of Suriname in 1987?
Keep it short and to the point. -4.51. What is the difference between the Gross enrolment ratio (%) of High income: nonOECD in 1986 and the Gross enrolment ratio (%) of Chile in 1988?
Provide a succinct answer. 22.19. What is the difference between the Gross enrolment ratio (%) in High income: nonOECD in 1986 and the Gross enrolment ratio (%) in Nigeria in 1988?
Give a very brief answer. 37.17. What is the difference between the Gross enrolment ratio (%) in High income: nonOECD in 1986 and the Gross enrolment ratio (%) in Suriname in 1988?
Keep it short and to the point. 32.29. What is the difference between the Gross enrolment ratio (%) in Chile in 1986 and the Gross enrolment ratio (%) in Nigeria in 1988?
Offer a very short reply. 12.98. What is the difference between the Gross enrolment ratio (%) in Chile in 1986 and the Gross enrolment ratio (%) in Suriname in 1988?
Give a very brief answer. 8.09. What is the difference between the Gross enrolment ratio (%) in Nigeria in 1986 and the Gross enrolment ratio (%) in Suriname in 1988?
Make the answer very short. -5.2. What is the difference between the Gross enrolment ratio (%) of High income: nonOECD in 1987 and the Gross enrolment ratio (%) of Chile in 1988?
Give a very brief answer. 22.8. What is the difference between the Gross enrolment ratio (%) of High income: nonOECD in 1987 and the Gross enrolment ratio (%) of Nigeria in 1988?
Provide a short and direct response. 37.79. What is the difference between the Gross enrolment ratio (%) in High income: nonOECD in 1987 and the Gross enrolment ratio (%) in Suriname in 1988?
Your response must be concise. 32.91. What is the difference between the Gross enrolment ratio (%) of Chile in 1987 and the Gross enrolment ratio (%) of Nigeria in 1988?
Ensure brevity in your answer.  14. What is the difference between the Gross enrolment ratio (%) in Chile in 1987 and the Gross enrolment ratio (%) in Suriname in 1988?
Keep it short and to the point. 9.11. What is the difference between the Gross enrolment ratio (%) in Nigeria in 1987 and the Gross enrolment ratio (%) in Suriname in 1988?
Ensure brevity in your answer.  -5.26. What is the average Gross enrolment ratio (%) of High income: nonOECD per year?
Offer a very short reply. 39.21. What is the average Gross enrolment ratio (%) of Chile per year?
Provide a succinct answer. 15.62. What is the average Gross enrolment ratio (%) of Nigeria per year?
Provide a succinct answer. 3.25. What is the average Gross enrolment ratio (%) of Suriname per year?
Offer a very short reply. 7.3. In the year 1982, what is the difference between the Gross enrolment ratio (%) in High income: nonOECD and Gross enrolment ratio (%) in Chile?
Provide a short and direct response. 23.42. In the year 1982, what is the difference between the Gross enrolment ratio (%) of High income: nonOECD and Gross enrolment ratio (%) of Nigeria?
Make the answer very short. 33.05. In the year 1982, what is the difference between the Gross enrolment ratio (%) of High income: nonOECD and Gross enrolment ratio (%) of Suriname?
Keep it short and to the point. 28.99. In the year 1982, what is the difference between the Gross enrolment ratio (%) in Chile and Gross enrolment ratio (%) in Nigeria?
Ensure brevity in your answer.  9.63. In the year 1982, what is the difference between the Gross enrolment ratio (%) of Chile and Gross enrolment ratio (%) of Suriname?
Give a very brief answer. 5.57. In the year 1982, what is the difference between the Gross enrolment ratio (%) in Nigeria and Gross enrolment ratio (%) in Suriname?
Your response must be concise. -4.06. In the year 1983, what is the difference between the Gross enrolment ratio (%) in High income: nonOECD and Gross enrolment ratio (%) in Chile?
Give a very brief answer. 23.07. In the year 1983, what is the difference between the Gross enrolment ratio (%) in High income: nonOECD and Gross enrolment ratio (%) in Nigeria?
Provide a succinct answer. 33.95. In the year 1983, what is the difference between the Gross enrolment ratio (%) in High income: nonOECD and Gross enrolment ratio (%) in Suriname?
Ensure brevity in your answer.  29.59. In the year 1983, what is the difference between the Gross enrolment ratio (%) in Chile and Gross enrolment ratio (%) in Nigeria?
Give a very brief answer. 10.89. In the year 1983, what is the difference between the Gross enrolment ratio (%) of Chile and Gross enrolment ratio (%) of Suriname?
Ensure brevity in your answer.  6.53. In the year 1983, what is the difference between the Gross enrolment ratio (%) of Nigeria and Gross enrolment ratio (%) of Suriname?
Your answer should be compact. -4.36. In the year 1984, what is the difference between the Gross enrolment ratio (%) in High income: nonOECD and Gross enrolment ratio (%) in Chile?
Keep it short and to the point. 23.41. In the year 1984, what is the difference between the Gross enrolment ratio (%) in High income: nonOECD and Gross enrolment ratio (%) in Nigeria?
Your answer should be compact. 34.93. In the year 1984, what is the difference between the Gross enrolment ratio (%) in High income: nonOECD and Gross enrolment ratio (%) in Suriname?
Offer a very short reply. 30.84. In the year 1984, what is the difference between the Gross enrolment ratio (%) in Chile and Gross enrolment ratio (%) in Nigeria?
Your answer should be very brief. 11.52. In the year 1984, what is the difference between the Gross enrolment ratio (%) in Chile and Gross enrolment ratio (%) in Suriname?
Your answer should be compact. 7.43. In the year 1984, what is the difference between the Gross enrolment ratio (%) of Nigeria and Gross enrolment ratio (%) of Suriname?
Provide a short and direct response. -4.09. In the year 1985, what is the difference between the Gross enrolment ratio (%) in High income: nonOECD and Gross enrolment ratio (%) in Chile?
Keep it short and to the point. 24.43. In the year 1985, what is the difference between the Gross enrolment ratio (%) in High income: nonOECD and Gross enrolment ratio (%) in Nigeria?
Your answer should be very brief. 36.33. In the year 1985, what is the difference between the Gross enrolment ratio (%) of High income: nonOECD and Gross enrolment ratio (%) of Suriname?
Ensure brevity in your answer.  32.89. In the year 1985, what is the difference between the Gross enrolment ratio (%) in Chile and Gross enrolment ratio (%) in Nigeria?
Provide a succinct answer. 11.9. In the year 1985, what is the difference between the Gross enrolment ratio (%) in Chile and Gross enrolment ratio (%) in Suriname?
Your answer should be very brief. 8.46. In the year 1985, what is the difference between the Gross enrolment ratio (%) in Nigeria and Gross enrolment ratio (%) in Suriname?
Offer a very short reply. -3.44. In the year 1986, what is the difference between the Gross enrolment ratio (%) of High income: nonOECD and Gross enrolment ratio (%) of Chile?
Make the answer very short. 24.19. In the year 1986, what is the difference between the Gross enrolment ratio (%) in High income: nonOECD and Gross enrolment ratio (%) in Nigeria?
Give a very brief answer. 37.48. In the year 1986, what is the difference between the Gross enrolment ratio (%) of High income: nonOECD and Gross enrolment ratio (%) of Suriname?
Offer a terse response. 34.56. In the year 1986, what is the difference between the Gross enrolment ratio (%) in Chile and Gross enrolment ratio (%) in Nigeria?
Keep it short and to the point. 13.29. In the year 1986, what is the difference between the Gross enrolment ratio (%) of Chile and Gross enrolment ratio (%) of Suriname?
Give a very brief answer. 10.37. In the year 1986, what is the difference between the Gross enrolment ratio (%) of Nigeria and Gross enrolment ratio (%) of Suriname?
Offer a terse response. -2.92. In the year 1987, what is the difference between the Gross enrolment ratio (%) in High income: nonOECD and Gross enrolment ratio (%) in Chile?
Your answer should be very brief. 23.8. In the year 1987, what is the difference between the Gross enrolment ratio (%) in High income: nonOECD and Gross enrolment ratio (%) in Nigeria?
Your response must be concise. 38.17. In the year 1987, what is the difference between the Gross enrolment ratio (%) in High income: nonOECD and Gross enrolment ratio (%) in Suriname?
Offer a terse response. 33.59. In the year 1987, what is the difference between the Gross enrolment ratio (%) of Chile and Gross enrolment ratio (%) of Nigeria?
Keep it short and to the point. 14.37. In the year 1987, what is the difference between the Gross enrolment ratio (%) of Chile and Gross enrolment ratio (%) of Suriname?
Your answer should be very brief. 9.8. In the year 1987, what is the difference between the Gross enrolment ratio (%) of Nigeria and Gross enrolment ratio (%) of Suriname?
Your response must be concise. -4.57. In the year 1988, what is the difference between the Gross enrolment ratio (%) in High income: nonOECD and Gross enrolment ratio (%) in Chile?
Ensure brevity in your answer.  22.8. In the year 1988, what is the difference between the Gross enrolment ratio (%) in High income: nonOECD and Gross enrolment ratio (%) in Nigeria?
Provide a succinct answer. 37.79. In the year 1988, what is the difference between the Gross enrolment ratio (%) of High income: nonOECD and Gross enrolment ratio (%) of Suriname?
Make the answer very short. 32.9. In the year 1988, what is the difference between the Gross enrolment ratio (%) of Chile and Gross enrolment ratio (%) of Nigeria?
Provide a succinct answer. 14.99. In the year 1988, what is the difference between the Gross enrolment ratio (%) of Chile and Gross enrolment ratio (%) of Suriname?
Offer a terse response. 10.1. In the year 1988, what is the difference between the Gross enrolment ratio (%) of Nigeria and Gross enrolment ratio (%) of Suriname?
Your answer should be very brief. -4.89. What is the ratio of the Gross enrolment ratio (%) in High income: nonOECD in 1982 to that in 1983?
Offer a very short reply. 0.97. What is the ratio of the Gross enrolment ratio (%) of Chile in 1982 to that in 1983?
Offer a very short reply. 0.89. What is the ratio of the Gross enrolment ratio (%) in Nigeria in 1982 to that in 1983?
Your response must be concise. 0.93. What is the ratio of the Gross enrolment ratio (%) of Suriname in 1982 to that in 1983?
Provide a succinct answer. 0.93. What is the ratio of the Gross enrolment ratio (%) in High income: nonOECD in 1982 to that in 1984?
Keep it short and to the point. 0.94. What is the ratio of the Gross enrolment ratio (%) of Chile in 1982 to that in 1984?
Offer a terse response. 0.85. What is the ratio of the Gross enrolment ratio (%) in Nigeria in 1982 to that in 1984?
Your answer should be compact. 0.89. What is the ratio of the Gross enrolment ratio (%) in Suriname in 1982 to that in 1984?
Your answer should be compact. 0.95. What is the ratio of the Gross enrolment ratio (%) of High income: nonOECD in 1982 to that in 1985?
Your response must be concise. 0.9. What is the ratio of the Gross enrolment ratio (%) of Chile in 1982 to that in 1985?
Offer a terse response. 0.8. What is the ratio of the Gross enrolment ratio (%) of Nigeria in 1982 to that in 1985?
Provide a short and direct response. 0.78. What is the ratio of the Gross enrolment ratio (%) of Suriname in 1982 to that in 1985?
Give a very brief answer. 0.98. What is the ratio of the Gross enrolment ratio (%) of High income: nonOECD in 1982 to that in 1986?
Provide a short and direct response. 0.87. What is the ratio of the Gross enrolment ratio (%) of Chile in 1982 to that in 1986?
Give a very brief answer. 0.73. What is the ratio of the Gross enrolment ratio (%) of Nigeria in 1982 to that in 1986?
Ensure brevity in your answer.  0.75. What is the ratio of the Gross enrolment ratio (%) of Suriname in 1982 to that in 1986?
Provide a short and direct response. 1.04. What is the ratio of the Gross enrolment ratio (%) in High income: nonOECD in 1982 to that in 1987?
Provide a succinct answer. 0.86. What is the ratio of the Gross enrolment ratio (%) of Chile in 1982 to that in 1987?
Offer a terse response. 0.69. What is the ratio of the Gross enrolment ratio (%) of Nigeria in 1982 to that in 1987?
Your answer should be very brief. 0.76. What is the ratio of the Gross enrolment ratio (%) in Suriname in 1982 to that in 1987?
Your response must be concise. 0.83. What is the ratio of the Gross enrolment ratio (%) of High income: nonOECD in 1982 to that in 1988?
Your response must be concise. 0.86. What is the ratio of the Gross enrolment ratio (%) of Chile in 1982 to that in 1988?
Provide a short and direct response. 0.65. What is the ratio of the Gross enrolment ratio (%) in Nigeria in 1982 to that in 1988?
Give a very brief answer. 0.69. What is the ratio of the Gross enrolment ratio (%) in Suriname in 1982 to that in 1988?
Your response must be concise. 0.77. What is the ratio of the Gross enrolment ratio (%) in High income: nonOECD in 1983 to that in 1984?
Ensure brevity in your answer.  0.97. What is the ratio of the Gross enrolment ratio (%) in Chile in 1983 to that in 1984?
Make the answer very short. 0.95. What is the ratio of the Gross enrolment ratio (%) of Nigeria in 1983 to that in 1984?
Your answer should be very brief. 0.95. What is the ratio of the Gross enrolment ratio (%) in Suriname in 1983 to that in 1984?
Your answer should be very brief. 1.02. What is the ratio of the Gross enrolment ratio (%) of High income: nonOECD in 1983 to that in 1985?
Ensure brevity in your answer.  0.93. What is the ratio of the Gross enrolment ratio (%) in Chile in 1983 to that in 1985?
Your answer should be very brief. 0.9. What is the ratio of the Gross enrolment ratio (%) in Nigeria in 1983 to that in 1985?
Your response must be concise. 0.84. What is the ratio of the Gross enrolment ratio (%) in Suriname in 1983 to that in 1985?
Your answer should be compact. 1.06. What is the ratio of the Gross enrolment ratio (%) in High income: nonOECD in 1983 to that in 1986?
Your answer should be very brief. 0.9. What is the ratio of the Gross enrolment ratio (%) of Chile in 1983 to that in 1986?
Keep it short and to the point. 0.82. What is the ratio of the Gross enrolment ratio (%) in Nigeria in 1983 to that in 1986?
Your response must be concise. 0.8. What is the ratio of the Gross enrolment ratio (%) in Suriname in 1983 to that in 1986?
Your response must be concise. 1.11. What is the ratio of the Gross enrolment ratio (%) in High income: nonOECD in 1983 to that in 1987?
Your response must be concise. 0.88. What is the ratio of the Gross enrolment ratio (%) of Chile in 1983 to that in 1987?
Provide a succinct answer. 0.77. What is the ratio of the Gross enrolment ratio (%) in Nigeria in 1983 to that in 1987?
Provide a succinct answer. 0.82. What is the ratio of the Gross enrolment ratio (%) in Suriname in 1983 to that in 1987?
Give a very brief answer. 0.9. What is the ratio of the Gross enrolment ratio (%) of High income: nonOECD in 1983 to that in 1988?
Provide a succinct answer. 0.88. What is the ratio of the Gross enrolment ratio (%) in Chile in 1983 to that in 1988?
Provide a short and direct response. 0.73. What is the ratio of the Gross enrolment ratio (%) of Nigeria in 1983 to that in 1988?
Provide a short and direct response. 0.74. What is the ratio of the Gross enrolment ratio (%) in Suriname in 1983 to that in 1988?
Make the answer very short. 0.82. What is the ratio of the Gross enrolment ratio (%) in High income: nonOECD in 1984 to that in 1985?
Your response must be concise. 0.95. What is the ratio of the Gross enrolment ratio (%) in Chile in 1984 to that in 1985?
Provide a succinct answer. 0.95. What is the ratio of the Gross enrolment ratio (%) of Nigeria in 1984 to that in 1985?
Offer a terse response. 0.88. What is the ratio of the Gross enrolment ratio (%) in Suriname in 1984 to that in 1985?
Make the answer very short. 1.04. What is the ratio of the Gross enrolment ratio (%) of High income: nonOECD in 1984 to that in 1986?
Make the answer very short. 0.92. What is the ratio of the Gross enrolment ratio (%) of Chile in 1984 to that in 1986?
Give a very brief answer. 0.86. What is the ratio of the Gross enrolment ratio (%) in Nigeria in 1984 to that in 1986?
Offer a terse response. 0.84. What is the ratio of the Gross enrolment ratio (%) in Suriname in 1984 to that in 1986?
Offer a terse response. 1.1. What is the ratio of the Gross enrolment ratio (%) of High income: nonOECD in 1984 to that in 1987?
Your answer should be very brief. 0.91. What is the ratio of the Gross enrolment ratio (%) in Chile in 1984 to that in 1987?
Offer a very short reply. 0.81. What is the ratio of the Gross enrolment ratio (%) of Nigeria in 1984 to that in 1987?
Your answer should be very brief. 0.86. What is the ratio of the Gross enrolment ratio (%) of High income: nonOECD in 1984 to that in 1988?
Your answer should be very brief. 0.91. What is the ratio of the Gross enrolment ratio (%) in Chile in 1984 to that in 1988?
Provide a succinct answer. 0.77. What is the ratio of the Gross enrolment ratio (%) in Nigeria in 1984 to that in 1988?
Make the answer very short. 0.78. What is the ratio of the Gross enrolment ratio (%) in Suriname in 1984 to that in 1988?
Give a very brief answer. 0.81. What is the ratio of the Gross enrolment ratio (%) of High income: nonOECD in 1985 to that in 1986?
Offer a very short reply. 0.97. What is the ratio of the Gross enrolment ratio (%) of Chile in 1985 to that in 1986?
Provide a succinct answer. 0.91. What is the ratio of the Gross enrolment ratio (%) of Nigeria in 1985 to that in 1986?
Make the answer very short. 0.96. What is the ratio of the Gross enrolment ratio (%) in Suriname in 1985 to that in 1986?
Keep it short and to the point. 1.06. What is the ratio of the Gross enrolment ratio (%) of High income: nonOECD in 1985 to that in 1987?
Ensure brevity in your answer.  0.95. What is the ratio of the Gross enrolment ratio (%) of Chile in 1985 to that in 1987?
Offer a very short reply. 0.86. What is the ratio of the Gross enrolment ratio (%) in Nigeria in 1985 to that in 1987?
Keep it short and to the point. 0.97. What is the ratio of the Gross enrolment ratio (%) of Suriname in 1985 to that in 1987?
Ensure brevity in your answer.  0.85. What is the ratio of the Gross enrolment ratio (%) of High income: nonOECD in 1985 to that in 1988?
Your response must be concise. 0.95. What is the ratio of the Gross enrolment ratio (%) of Chile in 1985 to that in 1988?
Provide a succinct answer. 0.81. What is the ratio of the Gross enrolment ratio (%) in Nigeria in 1985 to that in 1988?
Provide a succinct answer. 0.88. What is the ratio of the Gross enrolment ratio (%) in Suriname in 1985 to that in 1988?
Ensure brevity in your answer.  0.78. What is the ratio of the Gross enrolment ratio (%) in High income: nonOECD in 1986 to that in 1987?
Make the answer very short. 0.99. What is the ratio of the Gross enrolment ratio (%) in Chile in 1986 to that in 1987?
Offer a very short reply. 0.94. What is the ratio of the Gross enrolment ratio (%) in Nigeria in 1986 to that in 1987?
Your answer should be compact. 1.02. What is the ratio of the Gross enrolment ratio (%) in Suriname in 1986 to that in 1987?
Give a very brief answer. 0.8. What is the ratio of the Gross enrolment ratio (%) of Chile in 1986 to that in 1988?
Your response must be concise. 0.89. What is the ratio of the Gross enrolment ratio (%) in Nigeria in 1986 to that in 1988?
Provide a succinct answer. 0.92. What is the ratio of the Gross enrolment ratio (%) of Suriname in 1986 to that in 1988?
Your response must be concise. 0.74. What is the ratio of the Gross enrolment ratio (%) of High income: nonOECD in 1987 to that in 1988?
Provide a succinct answer. 1. What is the ratio of the Gross enrolment ratio (%) of Chile in 1987 to that in 1988?
Offer a very short reply. 0.95. What is the ratio of the Gross enrolment ratio (%) in Nigeria in 1987 to that in 1988?
Make the answer very short. 0.9. What is the ratio of the Gross enrolment ratio (%) of Suriname in 1987 to that in 1988?
Keep it short and to the point. 0.92. What is the difference between the highest and the second highest Gross enrolment ratio (%) in High income: nonOECD?
Your response must be concise. 0.01. What is the difference between the highest and the second highest Gross enrolment ratio (%) in Chile?
Offer a terse response. 0.99. What is the difference between the highest and the second highest Gross enrolment ratio (%) in Nigeria?
Provide a succinct answer. 0.31. What is the difference between the highest and the second highest Gross enrolment ratio (%) of Suriname?
Your response must be concise. 0.69. What is the difference between the highest and the lowest Gross enrolment ratio (%) in High income: nonOECD?
Your answer should be compact. 5.94. What is the difference between the highest and the lowest Gross enrolment ratio (%) in Chile?
Offer a terse response. 6.56. What is the difference between the highest and the lowest Gross enrolment ratio (%) of Nigeria?
Your response must be concise. 1.19. What is the difference between the highest and the lowest Gross enrolment ratio (%) of Suriname?
Ensure brevity in your answer.  2.28. 